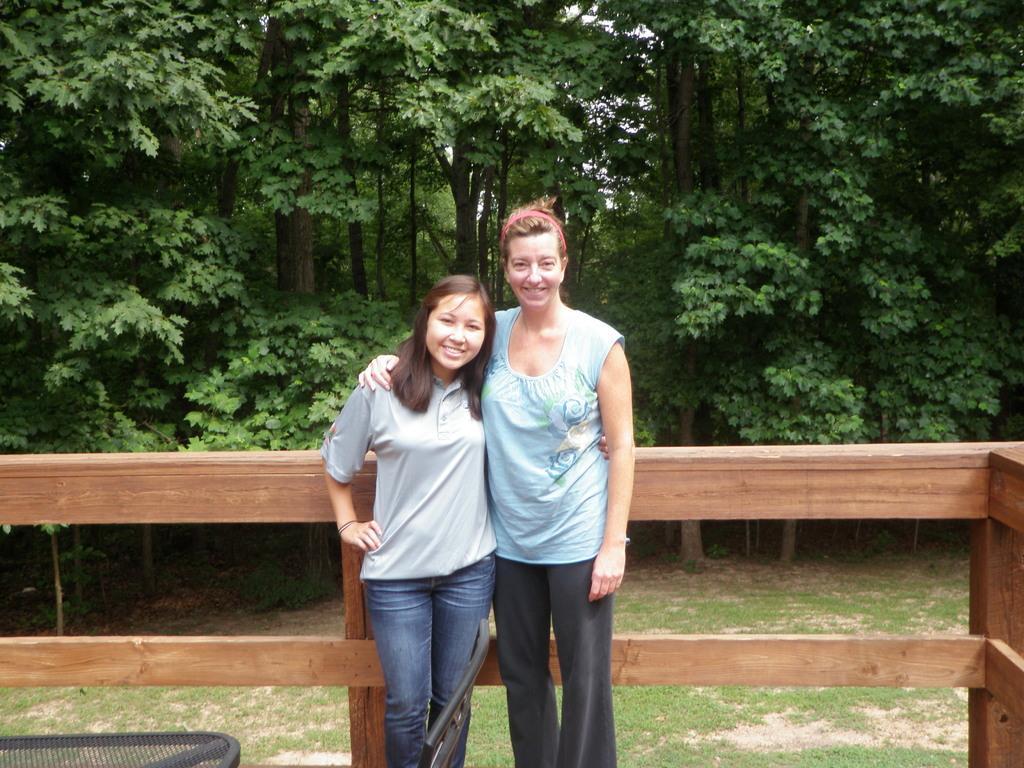Could you give a brief overview of what you see in this image? In this image we can see two people are standing and posing for a photo and there is a wooden fence and other objects. In the background, we can see some trees and the grass on the ground. 